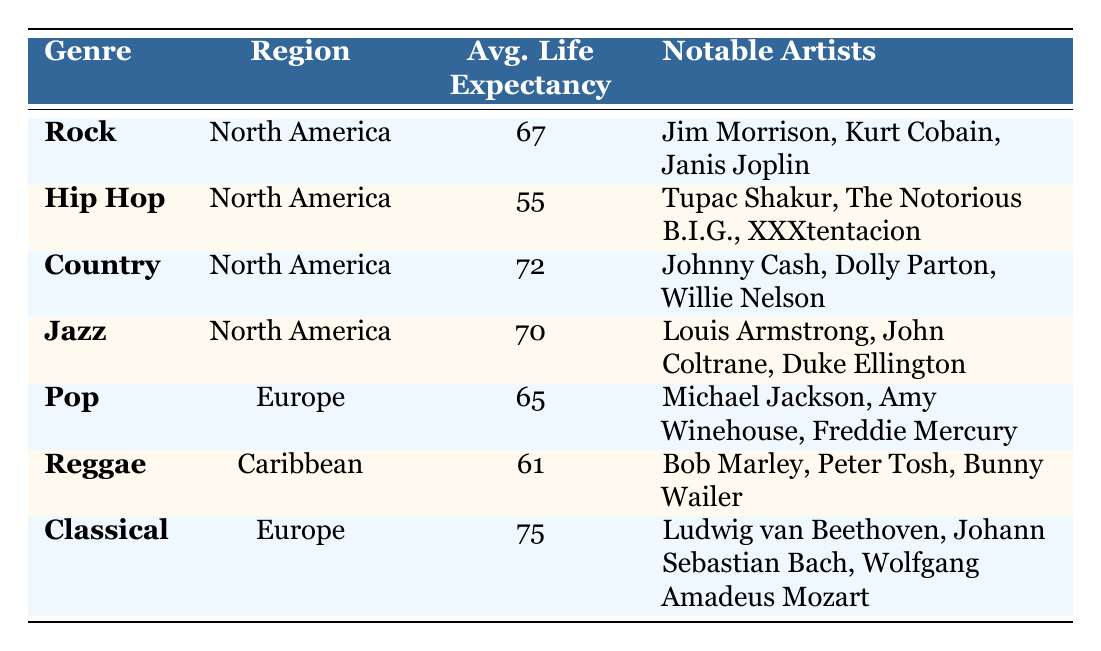What is the average life expectancy of musicians in the Hip Hop genre? According to the table, the average life expectancy for the Hip Hop genre in North America is stated to be 55.
Answer: 55 Which genre has the highest average life expectancy? The table shows that the Classical genre in Europe has the highest average life expectancy at 75.
Answer: 75 How many genres have an average life expectancy below 60? The genres listed with an average life expectancy below 60 are Hip Hop (55) and Reggae (61). Therefore, only Hip Hop meets the criteria, making a total of 1 genre.
Answer: 1 Which region is associated with the Rock genre? The table specifies that the Rock genre is associated with North America.
Answer: North America What is the difference between the average life expectancy of Country and Jazz musicians? The average life expectancy of Country musicians is 72, while that of Jazz musicians is 70. Therefore, the difference is 72 - 70 = 2 years.
Answer: 2 Is it true that the average life expectancy of Pop musicians is higher than that of Hip Hop musicians? The average life expectancy for Pop musicians is 65, while for Hip Hop musicians, it is 55. Since 65 is greater than 55, the statement is true.
Answer: Yes What is the average life expectancy of musicians across all genres listed? Adding the average life expectancy of all genres: (67 + 55 + 72 + 70 + 65 + 61 + 75) = 425. Then dividing by the number of genres (7), the average life expectancy across all genres is 425 / 7 = approximately 60.71.
Answer: 60.71 Which two notable artists are mentioned for the Reggae genre? The notable artists listed for the Reggae genre in the Caribbean are Bob Marley and Peter Tosh.
Answer: Bob Marley, Peter Tosh Are there any genres in the table that have an average life expectancy above 70? The table lists Country (72) and Classical (75) genres, both of which have an average life expectancy above 70. Therefore, the statement is true.
Answer: Yes 